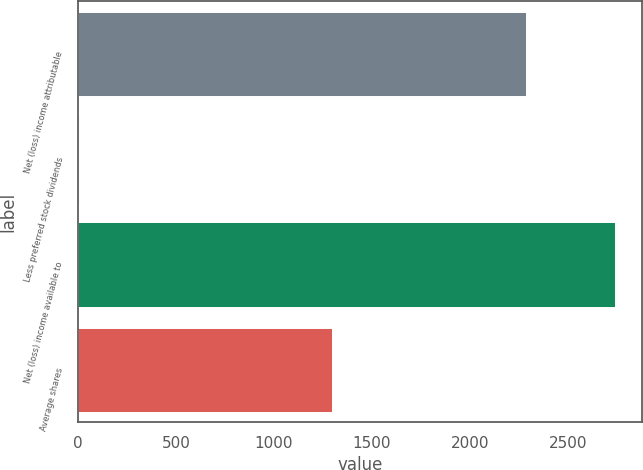Convert chart to OTSL. <chart><loc_0><loc_0><loc_500><loc_500><bar_chart><fcel>Net (loss) income attributable<fcel>Less preferred stock dividends<fcel>Net (loss) income available to<fcel>Average shares<nl><fcel>2285<fcel>2<fcel>2742<fcel>1298.5<nl></chart> 